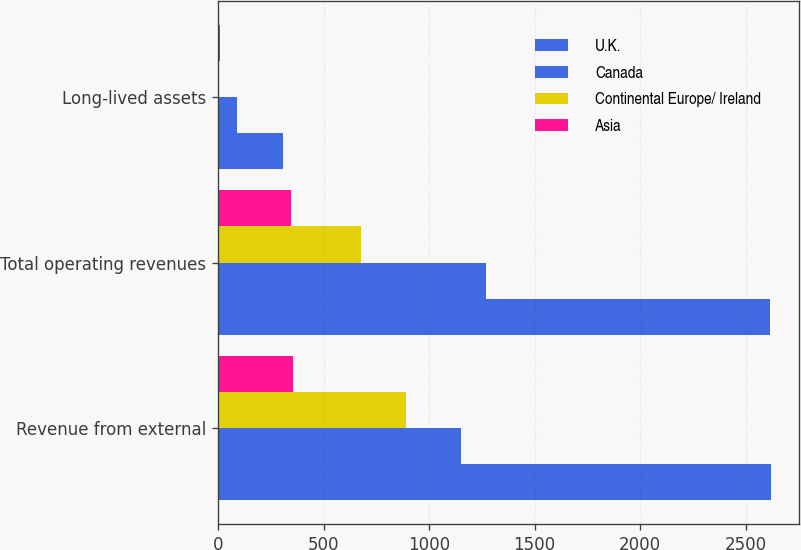Convert chart. <chart><loc_0><loc_0><loc_500><loc_500><stacked_bar_chart><ecel><fcel>Revenue from external<fcel>Total operating revenues<fcel>Long-lived assets<nl><fcel>U.K.<fcel>2622.1<fcel>2613.5<fcel>306.7<nl><fcel>Canada<fcel>1153<fcel>1267.4<fcel>88.3<nl><fcel>Continental Europe/ Ireland<fcel>891.9<fcel>675.2<fcel>6.8<nl><fcel>Asia<fcel>353.9<fcel>346.9<fcel>10<nl></chart> 